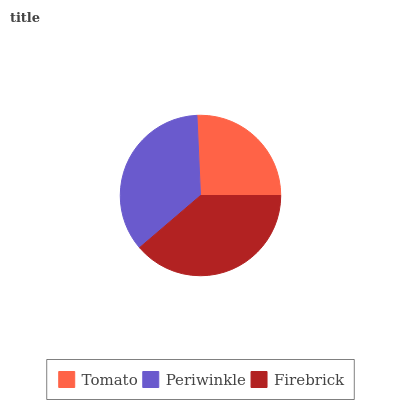Is Tomato the minimum?
Answer yes or no. Yes. Is Firebrick the maximum?
Answer yes or no. Yes. Is Periwinkle the minimum?
Answer yes or no. No. Is Periwinkle the maximum?
Answer yes or no. No. Is Periwinkle greater than Tomato?
Answer yes or no. Yes. Is Tomato less than Periwinkle?
Answer yes or no. Yes. Is Tomato greater than Periwinkle?
Answer yes or no. No. Is Periwinkle less than Tomato?
Answer yes or no. No. Is Periwinkle the high median?
Answer yes or no. Yes. Is Periwinkle the low median?
Answer yes or no. Yes. Is Firebrick the high median?
Answer yes or no. No. Is Tomato the low median?
Answer yes or no. No. 